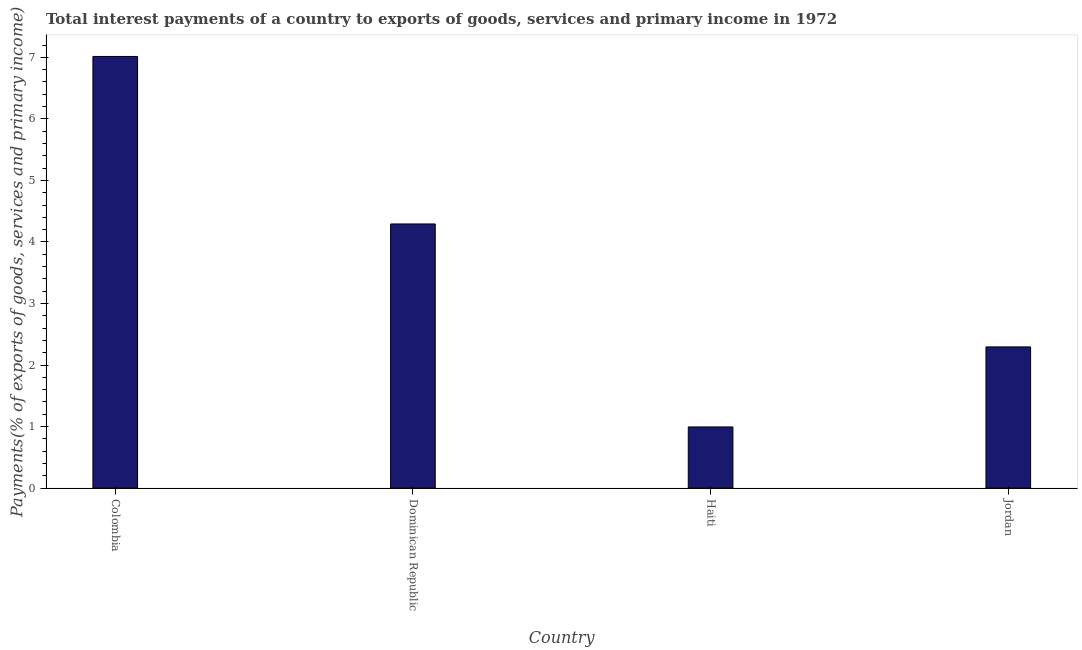Does the graph contain grids?
Ensure brevity in your answer.  No. What is the title of the graph?
Keep it short and to the point. Total interest payments of a country to exports of goods, services and primary income in 1972. What is the label or title of the X-axis?
Offer a terse response. Country. What is the label or title of the Y-axis?
Make the answer very short. Payments(% of exports of goods, services and primary income). What is the total interest payments on external debt in Colombia?
Keep it short and to the point. 7.01. Across all countries, what is the maximum total interest payments on external debt?
Your answer should be compact. 7.01. Across all countries, what is the minimum total interest payments on external debt?
Give a very brief answer. 0.99. In which country was the total interest payments on external debt minimum?
Offer a very short reply. Haiti. What is the sum of the total interest payments on external debt?
Provide a short and direct response. 14.59. What is the difference between the total interest payments on external debt in Dominican Republic and Jordan?
Make the answer very short. 2. What is the average total interest payments on external debt per country?
Offer a very short reply. 3.65. What is the median total interest payments on external debt?
Keep it short and to the point. 3.29. In how many countries, is the total interest payments on external debt greater than 6.4 %?
Give a very brief answer. 1. What is the ratio of the total interest payments on external debt in Haiti to that in Jordan?
Give a very brief answer. 0.43. Is the difference between the total interest payments on external debt in Dominican Republic and Haiti greater than the difference between any two countries?
Provide a short and direct response. No. What is the difference between the highest and the second highest total interest payments on external debt?
Your response must be concise. 2.72. What is the difference between the highest and the lowest total interest payments on external debt?
Provide a succinct answer. 6.02. In how many countries, is the total interest payments on external debt greater than the average total interest payments on external debt taken over all countries?
Your answer should be very brief. 2. How many bars are there?
Provide a succinct answer. 4. Are the values on the major ticks of Y-axis written in scientific E-notation?
Your response must be concise. No. What is the Payments(% of exports of goods, services and primary income) in Colombia?
Ensure brevity in your answer.  7.01. What is the Payments(% of exports of goods, services and primary income) in Dominican Republic?
Offer a terse response. 4.29. What is the Payments(% of exports of goods, services and primary income) of Haiti?
Offer a very short reply. 0.99. What is the Payments(% of exports of goods, services and primary income) of Jordan?
Offer a terse response. 2.29. What is the difference between the Payments(% of exports of goods, services and primary income) in Colombia and Dominican Republic?
Offer a very short reply. 2.72. What is the difference between the Payments(% of exports of goods, services and primary income) in Colombia and Haiti?
Ensure brevity in your answer.  6.02. What is the difference between the Payments(% of exports of goods, services and primary income) in Colombia and Jordan?
Offer a terse response. 4.72. What is the difference between the Payments(% of exports of goods, services and primary income) in Dominican Republic and Haiti?
Give a very brief answer. 3.3. What is the difference between the Payments(% of exports of goods, services and primary income) in Dominican Republic and Jordan?
Offer a terse response. 2. What is the difference between the Payments(% of exports of goods, services and primary income) in Haiti and Jordan?
Provide a succinct answer. -1.3. What is the ratio of the Payments(% of exports of goods, services and primary income) in Colombia to that in Dominican Republic?
Offer a very short reply. 1.63. What is the ratio of the Payments(% of exports of goods, services and primary income) in Colombia to that in Haiti?
Keep it short and to the point. 7.06. What is the ratio of the Payments(% of exports of goods, services and primary income) in Colombia to that in Jordan?
Make the answer very short. 3.06. What is the ratio of the Payments(% of exports of goods, services and primary income) in Dominican Republic to that in Haiti?
Ensure brevity in your answer.  4.32. What is the ratio of the Payments(% of exports of goods, services and primary income) in Dominican Republic to that in Jordan?
Your answer should be compact. 1.87. What is the ratio of the Payments(% of exports of goods, services and primary income) in Haiti to that in Jordan?
Provide a short and direct response. 0.43. 